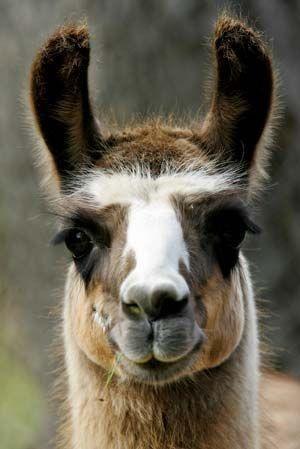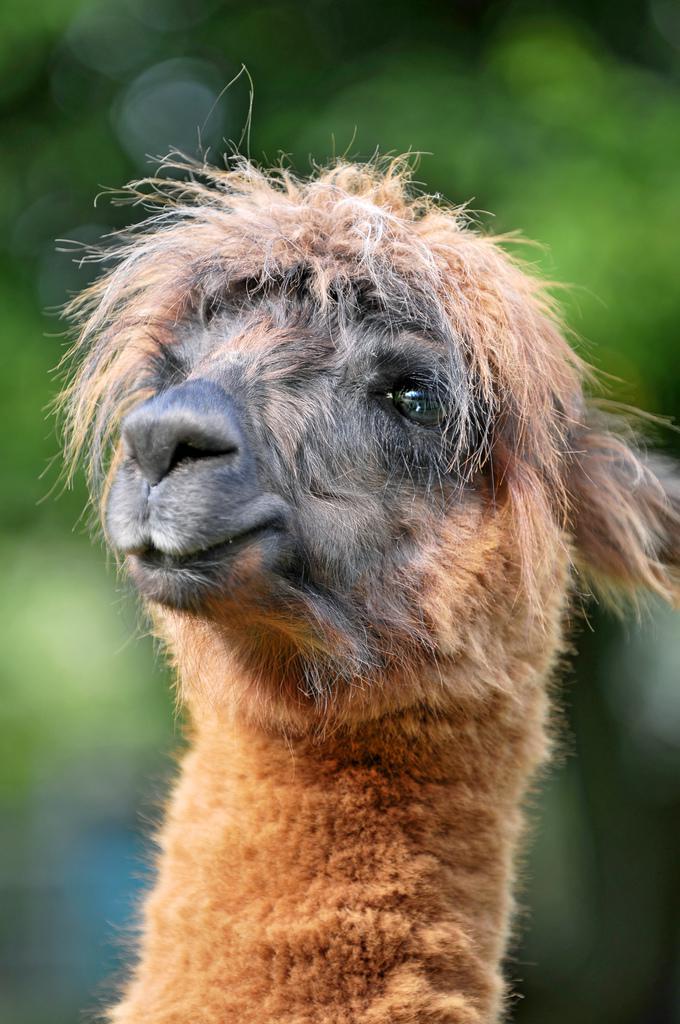The first image is the image on the left, the second image is the image on the right. Evaluate the accuracy of this statement regarding the images: "One image shows a forward-facing llama with dark ears and protruding lower teeth, and the other image shows a forward-facing white llama.". Is it true? Answer yes or no. No. 